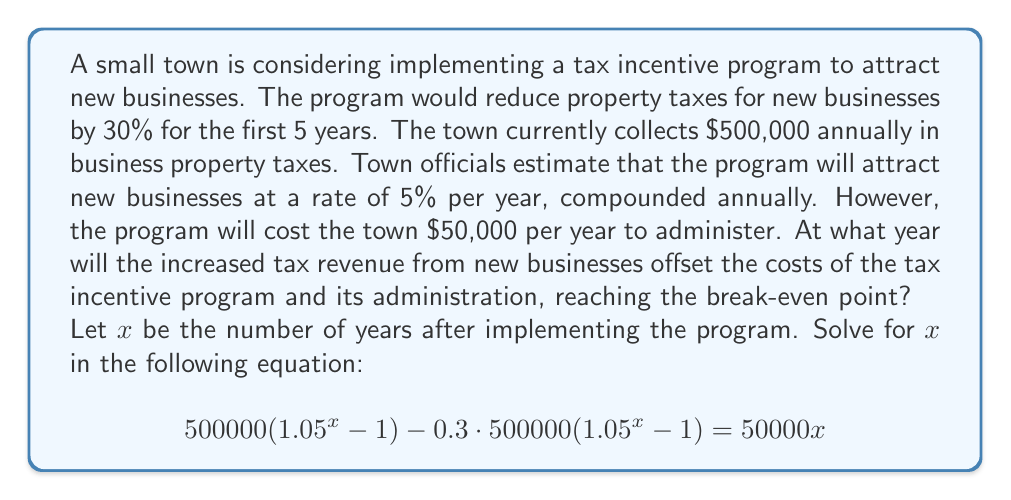Can you solve this math problem? Let's break down this problem step-by-step:

1) First, let's understand what each part of the equation represents:
   - $500000(1.05^x - 1)$: This is the additional tax revenue from new businesses.
   - $0.3 \cdot 500000(1.05^x - 1)$: This is the amount of tax reduction due to the incentive.
   - $50000x$: This is the cumulative cost of administering the program over $x$ years.

2) Simplify the left side of the equation:
   $$ 500000(1.05^x - 1) - 150000(1.05^x - 1) = 50000x $$
   $$ 350000(1.05^x - 1) = 50000x $$

3) Expand the brackets:
   $$ 350000 \cdot 1.05^x - 350000 = 50000x $$

4) Rearrange the equation:
   $$ 350000 \cdot 1.05^x = 50000x + 350000 $$

5) Divide both sides by 350000:
   $$ 1.05^x = \frac{50000x}{350000} + 1 $$
   $$ 1.05^x = \frac{x}{7} + 1 $$

6) This equation cannot be solved algebraically. We need to use numerical methods or graphing to find the solution.

7) Using a graphing calculator or software, we can plot $y = 1.05^x$ and $y = \frac{x}{7} + 1$ and find their intersection point.

8) The intersection point occurs at approximately $x = 11.67$.

9) Since we're dealing with whole years, we round up to 12 years.
Answer: The break-even point will occur after 12 years. 